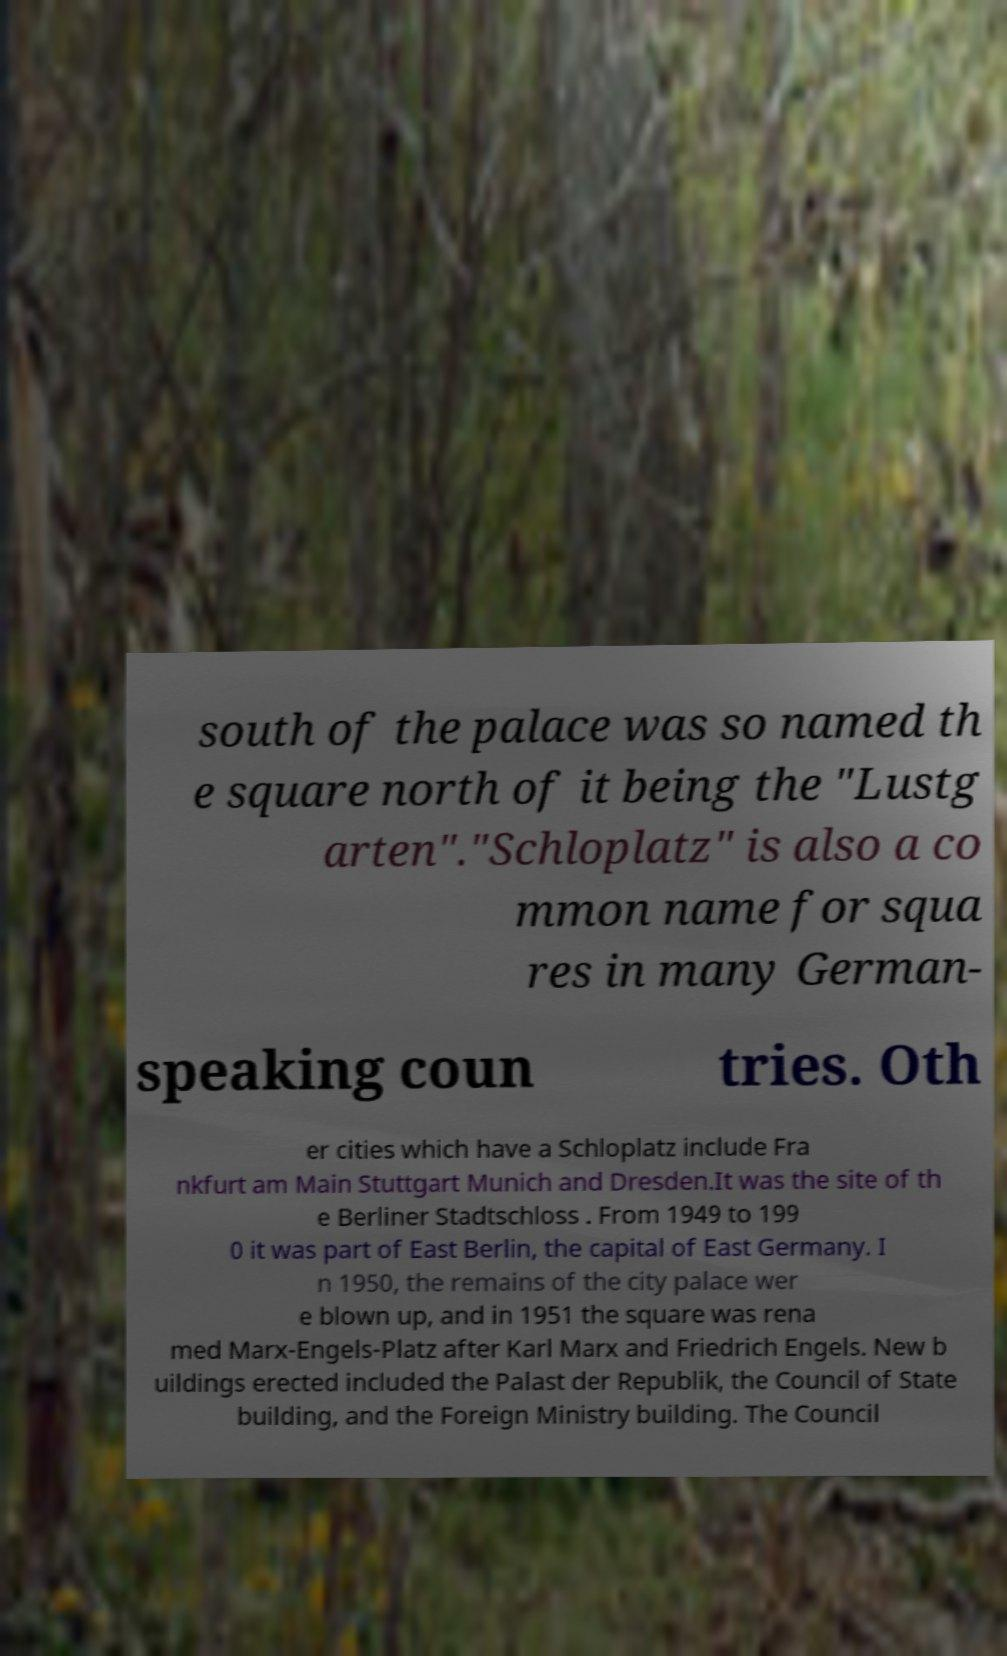Can you read and provide the text displayed in the image?This photo seems to have some interesting text. Can you extract and type it out for me? south of the palace was so named th e square north of it being the "Lustg arten"."Schloplatz" is also a co mmon name for squa res in many German- speaking coun tries. Oth er cities which have a Schloplatz include Fra nkfurt am Main Stuttgart Munich and Dresden.It was the site of th e Berliner Stadtschloss . From 1949 to 199 0 it was part of East Berlin, the capital of East Germany. I n 1950, the remains of the city palace wer e blown up, and in 1951 the square was rena med Marx-Engels-Platz after Karl Marx and Friedrich Engels. New b uildings erected included the Palast der Republik, the Council of State building, and the Foreign Ministry building. The Council 